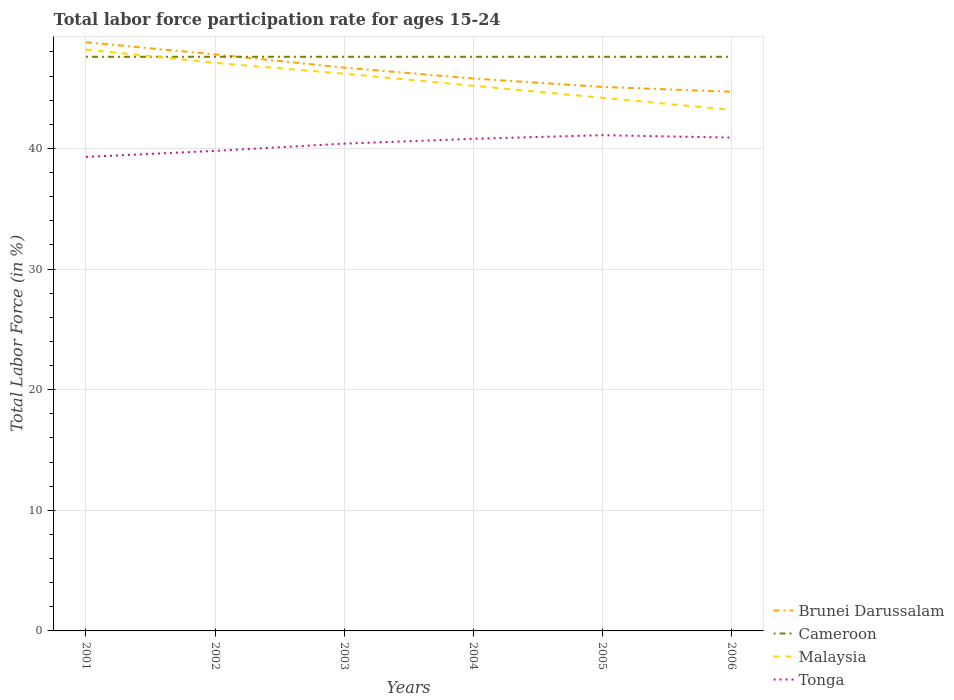How many different coloured lines are there?
Make the answer very short. 4. Does the line corresponding to Malaysia intersect with the line corresponding to Cameroon?
Make the answer very short. Yes. Is the number of lines equal to the number of legend labels?
Ensure brevity in your answer.  Yes. Across all years, what is the maximum labor force participation rate in Malaysia?
Your answer should be very brief. 43.2. What is the total labor force participation rate in Malaysia in the graph?
Ensure brevity in your answer.  2. What is the difference between the highest and the second highest labor force participation rate in Brunei Darussalam?
Offer a terse response. 4.1. Is the labor force participation rate in Brunei Darussalam strictly greater than the labor force participation rate in Malaysia over the years?
Your answer should be very brief. No. How many lines are there?
Your answer should be compact. 4. Are the values on the major ticks of Y-axis written in scientific E-notation?
Your answer should be compact. No. Does the graph contain any zero values?
Ensure brevity in your answer.  No. How are the legend labels stacked?
Offer a very short reply. Vertical. What is the title of the graph?
Keep it short and to the point. Total labor force participation rate for ages 15-24. What is the label or title of the X-axis?
Offer a terse response. Years. What is the label or title of the Y-axis?
Make the answer very short. Total Labor Force (in %). What is the Total Labor Force (in %) in Brunei Darussalam in 2001?
Your answer should be very brief. 48.8. What is the Total Labor Force (in %) of Cameroon in 2001?
Offer a terse response. 47.6. What is the Total Labor Force (in %) in Malaysia in 2001?
Keep it short and to the point. 48.2. What is the Total Labor Force (in %) in Tonga in 2001?
Your answer should be very brief. 39.3. What is the Total Labor Force (in %) in Brunei Darussalam in 2002?
Provide a short and direct response. 47.8. What is the Total Labor Force (in %) of Cameroon in 2002?
Make the answer very short. 47.6. What is the Total Labor Force (in %) of Malaysia in 2002?
Provide a succinct answer. 47.1. What is the Total Labor Force (in %) of Tonga in 2002?
Ensure brevity in your answer.  39.8. What is the Total Labor Force (in %) in Brunei Darussalam in 2003?
Ensure brevity in your answer.  46.7. What is the Total Labor Force (in %) of Cameroon in 2003?
Your answer should be very brief. 47.6. What is the Total Labor Force (in %) in Malaysia in 2003?
Keep it short and to the point. 46.2. What is the Total Labor Force (in %) of Tonga in 2003?
Provide a succinct answer. 40.4. What is the Total Labor Force (in %) of Brunei Darussalam in 2004?
Your answer should be very brief. 45.8. What is the Total Labor Force (in %) in Cameroon in 2004?
Ensure brevity in your answer.  47.6. What is the Total Labor Force (in %) of Malaysia in 2004?
Your response must be concise. 45.2. What is the Total Labor Force (in %) in Tonga in 2004?
Your response must be concise. 40.8. What is the Total Labor Force (in %) of Brunei Darussalam in 2005?
Provide a short and direct response. 45.1. What is the Total Labor Force (in %) in Cameroon in 2005?
Your answer should be very brief. 47.6. What is the Total Labor Force (in %) of Malaysia in 2005?
Your answer should be compact. 44.2. What is the Total Labor Force (in %) in Tonga in 2005?
Provide a succinct answer. 41.1. What is the Total Labor Force (in %) of Brunei Darussalam in 2006?
Keep it short and to the point. 44.7. What is the Total Labor Force (in %) of Cameroon in 2006?
Ensure brevity in your answer.  47.6. What is the Total Labor Force (in %) of Malaysia in 2006?
Offer a terse response. 43.2. What is the Total Labor Force (in %) of Tonga in 2006?
Give a very brief answer. 40.9. Across all years, what is the maximum Total Labor Force (in %) of Brunei Darussalam?
Give a very brief answer. 48.8. Across all years, what is the maximum Total Labor Force (in %) in Cameroon?
Your response must be concise. 47.6. Across all years, what is the maximum Total Labor Force (in %) in Malaysia?
Your response must be concise. 48.2. Across all years, what is the maximum Total Labor Force (in %) in Tonga?
Keep it short and to the point. 41.1. Across all years, what is the minimum Total Labor Force (in %) in Brunei Darussalam?
Offer a terse response. 44.7. Across all years, what is the minimum Total Labor Force (in %) of Cameroon?
Provide a succinct answer. 47.6. Across all years, what is the minimum Total Labor Force (in %) of Malaysia?
Your answer should be very brief. 43.2. Across all years, what is the minimum Total Labor Force (in %) of Tonga?
Keep it short and to the point. 39.3. What is the total Total Labor Force (in %) in Brunei Darussalam in the graph?
Ensure brevity in your answer.  278.9. What is the total Total Labor Force (in %) of Cameroon in the graph?
Keep it short and to the point. 285.6. What is the total Total Labor Force (in %) of Malaysia in the graph?
Provide a succinct answer. 274.1. What is the total Total Labor Force (in %) in Tonga in the graph?
Provide a short and direct response. 242.3. What is the difference between the Total Labor Force (in %) in Brunei Darussalam in 2001 and that in 2002?
Ensure brevity in your answer.  1. What is the difference between the Total Labor Force (in %) in Brunei Darussalam in 2001 and that in 2003?
Your answer should be compact. 2.1. What is the difference between the Total Labor Force (in %) in Tonga in 2001 and that in 2003?
Provide a short and direct response. -1.1. What is the difference between the Total Labor Force (in %) in Tonga in 2001 and that in 2004?
Your answer should be compact. -1.5. What is the difference between the Total Labor Force (in %) of Cameroon in 2001 and that in 2005?
Your response must be concise. 0. What is the difference between the Total Labor Force (in %) in Tonga in 2001 and that in 2005?
Ensure brevity in your answer.  -1.8. What is the difference between the Total Labor Force (in %) of Brunei Darussalam in 2001 and that in 2006?
Make the answer very short. 4.1. What is the difference between the Total Labor Force (in %) of Cameroon in 2001 and that in 2006?
Offer a terse response. 0. What is the difference between the Total Labor Force (in %) in Malaysia in 2001 and that in 2006?
Keep it short and to the point. 5. What is the difference between the Total Labor Force (in %) in Tonga in 2002 and that in 2003?
Provide a succinct answer. -0.6. What is the difference between the Total Labor Force (in %) of Brunei Darussalam in 2002 and that in 2004?
Offer a terse response. 2. What is the difference between the Total Labor Force (in %) in Cameroon in 2002 and that in 2004?
Give a very brief answer. 0. What is the difference between the Total Labor Force (in %) of Malaysia in 2002 and that in 2004?
Provide a succinct answer. 1.9. What is the difference between the Total Labor Force (in %) in Tonga in 2002 and that in 2004?
Provide a short and direct response. -1. What is the difference between the Total Labor Force (in %) in Malaysia in 2002 and that in 2005?
Keep it short and to the point. 2.9. What is the difference between the Total Labor Force (in %) of Brunei Darussalam in 2002 and that in 2006?
Provide a succinct answer. 3.1. What is the difference between the Total Labor Force (in %) of Cameroon in 2002 and that in 2006?
Your answer should be compact. 0. What is the difference between the Total Labor Force (in %) of Tonga in 2002 and that in 2006?
Provide a succinct answer. -1.1. What is the difference between the Total Labor Force (in %) of Brunei Darussalam in 2003 and that in 2004?
Provide a succinct answer. 0.9. What is the difference between the Total Labor Force (in %) in Malaysia in 2003 and that in 2004?
Keep it short and to the point. 1. What is the difference between the Total Labor Force (in %) in Brunei Darussalam in 2003 and that in 2005?
Keep it short and to the point. 1.6. What is the difference between the Total Labor Force (in %) in Tonga in 2003 and that in 2005?
Offer a very short reply. -0.7. What is the difference between the Total Labor Force (in %) of Brunei Darussalam in 2003 and that in 2006?
Provide a short and direct response. 2. What is the difference between the Total Labor Force (in %) in Tonga in 2003 and that in 2006?
Ensure brevity in your answer.  -0.5. What is the difference between the Total Labor Force (in %) in Brunei Darussalam in 2004 and that in 2005?
Your answer should be compact. 0.7. What is the difference between the Total Labor Force (in %) of Cameroon in 2004 and that in 2005?
Provide a succinct answer. 0. What is the difference between the Total Labor Force (in %) of Malaysia in 2004 and that in 2005?
Your answer should be very brief. 1. What is the difference between the Total Labor Force (in %) in Brunei Darussalam in 2004 and that in 2006?
Provide a short and direct response. 1.1. What is the difference between the Total Labor Force (in %) in Tonga in 2004 and that in 2006?
Ensure brevity in your answer.  -0.1. What is the difference between the Total Labor Force (in %) of Brunei Darussalam in 2005 and that in 2006?
Provide a succinct answer. 0.4. What is the difference between the Total Labor Force (in %) of Cameroon in 2005 and that in 2006?
Provide a short and direct response. 0. What is the difference between the Total Labor Force (in %) of Brunei Darussalam in 2001 and the Total Labor Force (in %) of Malaysia in 2002?
Keep it short and to the point. 1.7. What is the difference between the Total Labor Force (in %) of Malaysia in 2001 and the Total Labor Force (in %) of Tonga in 2002?
Make the answer very short. 8.4. What is the difference between the Total Labor Force (in %) in Brunei Darussalam in 2001 and the Total Labor Force (in %) in Cameroon in 2003?
Offer a very short reply. 1.2. What is the difference between the Total Labor Force (in %) in Brunei Darussalam in 2001 and the Total Labor Force (in %) in Malaysia in 2003?
Ensure brevity in your answer.  2.6. What is the difference between the Total Labor Force (in %) of Brunei Darussalam in 2001 and the Total Labor Force (in %) of Tonga in 2003?
Give a very brief answer. 8.4. What is the difference between the Total Labor Force (in %) in Cameroon in 2001 and the Total Labor Force (in %) in Malaysia in 2003?
Your answer should be very brief. 1.4. What is the difference between the Total Labor Force (in %) of Cameroon in 2001 and the Total Labor Force (in %) of Tonga in 2003?
Make the answer very short. 7.2. What is the difference between the Total Labor Force (in %) in Cameroon in 2001 and the Total Labor Force (in %) in Malaysia in 2004?
Provide a succinct answer. 2.4. What is the difference between the Total Labor Force (in %) in Brunei Darussalam in 2001 and the Total Labor Force (in %) in Cameroon in 2005?
Give a very brief answer. 1.2. What is the difference between the Total Labor Force (in %) of Cameroon in 2001 and the Total Labor Force (in %) of Malaysia in 2005?
Ensure brevity in your answer.  3.4. What is the difference between the Total Labor Force (in %) of Malaysia in 2001 and the Total Labor Force (in %) of Tonga in 2005?
Keep it short and to the point. 7.1. What is the difference between the Total Labor Force (in %) of Brunei Darussalam in 2001 and the Total Labor Force (in %) of Cameroon in 2006?
Offer a very short reply. 1.2. What is the difference between the Total Labor Force (in %) of Cameroon in 2001 and the Total Labor Force (in %) of Malaysia in 2006?
Offer a very short reply. 4.4. What is the difference between the Total Labor Force (in %) of Cameroon in 2001 and the Total Labor Force (in %) of Tonga in 2006?
Give a very brief answer. 6.7. What is the difference between the Total Labor Force (in %) in Malaysia in 2001 and the Total Labor Force (in %) in Tonga in 2006?
Keep it short and to the point. 7.3. What is the difference between the Total Labor Force (in %) of Brunei Darussalam in 2002 and the Total Labor Force (in %) of Cameroon in 2003?
Ensure brevity in your answer.  0.2. What is the difference between the Total Labor Force (in %) in Brunei Darussalam in 2002 and the Total Labor Force (in %) in Cameroon in 2004?
Give a very brief answer. 0.2. What is the difference between the Total Labor Force (in %) of Brunei Darussalam in 2002 and the Total Labor Force (in %) of Tonga in 2004?
Ensure brevity in your answer.  7. What is the difference between the Total Labor Force (in %) in Brunei Darussalam in 2002 and the Total Labor Force (in %) in Cameroon in 2005?
Your answer should be compact. 0.2. What is the difference between the Total Labor Force (in %) of Brunei Darussalam in 2002 and the Total Labor Force (in %) of Malaysia in 2005?
Provide a succinct answer. 3.6. What is the difference between the Total Labor Force (in %) of Cameroon in 2002 and the Total Labor Force (in %) of Malaysia in 2005?
Provide a succinct answer. 3.4. What is the difference between the Total Labor Force (in %) in Brunei Darussalam in 2002 and the Total Labor Force (in %) in Tonga in 2006?
Give a very brief answer. 6.9. What is the difference between the Total Labor Force (in %) of Cameroon in 2002 and the Total Labor Force (in %) of Malaysia in 2006?
Your answer should be very brief. 4.4. What is the difference between the Total Labor Force (in %) of Cameroon in 2002 and the Total Labor Force (in %) of Tonga in 2006?
Ensure brevity in your answer.  6.7. What is the difference between the Total Labor Force (in %) in Cameroon in 2003 and the Total Labor Force (in %) in Malaysia in 2004?
Ensure brevity in your answer.  2.4. What is the difference between the Total Labor Force (in %) in Cameroon in 2003 and the Total Labor Force (in %) in Tonga in 2004?
Offer a terse response. 6.8. What is the difference between the Total Labor Force (in %) of Malaysia in 2003 and the Total Labor Force (in %) of Tonga in 2004?
Your answer should be compact. 5.4. What is the difference between the Total Labor Force (in %) of Brunei Darussalam in 2003 and the Total Labor Force (in %) of Tonga in 2005?
Your answer should be very brief. 5.6. What is the difference between the Total Labor Force (in %) of Cameroon in 2003 and the Total Labor Force (in %) of Tonga in 2005?
Your answer should be very brief. 6.5. What is the difference between the Total Labor Force (in %) of Malaysia in 2003 and the Total Labor Force (in %) of Tonga in 2005?
Keep it short and to the point. 5.1. What is the difference between the Total Labor Force (in %) of Brunei Darussalam in 2003 and the Total Labor Force (in %) of Malaysia in 2006?
Make the answer very short. 3.5. What is the difference between the Total Labor Force (in %) of Cameroon in 2003 and the Total Labor Force (in %) of Malaysia in 2006?
Give a very brief answer. 4.4. What is the difference between the Total Labor Force (in %) in Malaysia in 2003 and the Total Labor Force (in %) in Tonga in 2006?
Make the answer very short. 5.3. What is the difference between the Total Labor Force (in %) in Cameroon in 2004 and the Total Labor Force (in %) in Malaysia in 2005?
Offer a terse response. 3.4. What is the difference between the Total Labor Force (in %) in Malaysia in 2004 and the Total Labor Force (in %) in Tonga in 2005?
Make the answer very short. 4.1. What is the difference between the Total Labor Force (in %) in Brunei Darussalam in 2004 and the Total Labor Force (in %) in Cameroon in 2006?
Keep it short and to the point. -1.8. What is the difference between the Total Labor Force (in %) of Brunei Darussalam in 2004 and the Total Labor Force (in %) of Tonga in 2006?
Offer a very short reply. 4.9. What is the difference between the Total Labor Force (in %) of Cameroon in 2004 and the Total Labor Force (in %) of Malaysia in 2006?
Keep it short and to the point. 4.4. What is the difference between the Total Labor Force (in %) in Cameroon in 2004 and the Total Labor Force (in %) in Tonga in 2006?
Provide a succinct answer. 6.7. What is the difference between the Total Labor Force (in %) in Malaysia in 2004 and the Total Labor Force (in %) in Tonga in 2006?
Give a very brief answer. 4.3. What is the difference between the Total Labor Force (in %) in Brunei Darussalam in 2005 and the Total Labor Force (in %) in Malaysia in 2006?
Provide a short and direct response. 1.9. What is the average Total Labor Force (in %) of Brunei Darussalam per year?
Your answer should be very brief. 46.48. What is the average Total Labor Force (in %) in Cameroon per year?
Offer a terse response. 47.6. What is the average Total Labor Force (in %) in Malaysia per year?
Offer a very short reply. 45.68. What is the average Total Labor Force (in %) in Tonga per year?
Give a very brief answer. 40.38. In the year 2001, what is the difference between the Total Labor Force (in %) in Brunei Darussalam and Total Labor Force (in %) in Tonga?
Offer a terse response. 9.5. In the year 2001, what is the difference between the Total Labor Force (in %) in Cameroon and Total Labor Force (in %) in Tonga?
Your answer should be very brief. 8.3. In the year 2001, what is the difference between the Total Labor Force (in %) of Malaysia and Total Labor Force (in %) of Tonga?
Your response must be concise. 8.9. In the year 2002, what is the difference between the Total Labor Force (in %) of Brunei Darussalam and Total Labor Force (in %) of Cameroon?
Your answer should be very brief. 0.2. In the year 2002, what is the difference between the Total Labor Force (in %) in Brunei Darussalam and Total Labor Force (in %) in Malaysia?
Your answer should be very brief. 0.7. In the year 2002, what is the difference between the Total Labor Force (in %) of Brunei Darussalam and Total Labor Force (in %) of Tonga?
Provide a short and direct response. 8. In the year 2002, what is the difference between the Total Labor Force (in %) of Malaysia and Total Labor Force (in %) of Tonga?
Keep it short and to the point. 7.3. In the year 2003, what is the difference between the Total Labor Force (in %) in Brunei Darussalam and Total Labor Force (in %) in Malaysia?
Ensure brevity in your answer.  0.5. In the year 2003, what is the difference between the Total Labor Force (in %) of Brunei Darussalam and Total Labor Force (in %) of Tonga?
Ensure brevity in your answer.  6.3. In the year 2003, what is the difference between the Total Labor Force (in %) in Cameroon and Total Labor Force (in %) in Malaysia?
Your response must be concise. 1.4. In the year 2003, what is the difference between the Total Labor Force (in %) of Malaysia and Total Labor Force (in %) of Tonga?
Your response must be concise. 5.8. In the year 2004, what is the difference between the Total Labor Force (in %) in Brunei Darussalam and Total Labor Force (in %) in Cameroon?
Make the answer very short. -1.8. In the year 2004, what is the difference between the Total Labor Force (in %) in Brunei Darussalam and Total Labor Force (in %) in Malaysia?
Your answer should be very brief. 0.6. In the year 2004, what is the difference between the Total Labor Force (in %) of Brunei Darussalam and Total Labor Force (in %) of Tonga?
Make the answer very short. 5. In the year 2004, what is the difference between the Total Labor Force (in %) of Cameroon and Total Labor Force (in %) of Malaysia?
Ensure brevity in your answer.  2.4. In the year 2005, what is the difference between the Total Labor Force (in %) in Brunei Darussalam and Total Labor Force (in %) in Cameroon?
Provide a short and direct response. -2.5. In the year 2005, what is the difference between the Total Labor Force (in %) of Brunei Darussalam and Total Labor Force (in %) of Tonga?
Your answer should be very brief. 4. In the year 2005, what is the difference between the Total Labor Force (in %) in Cameroon and Total Labor Force (in %) in Malaysia?
Your answer should be compact. 3.4. In the year 2005, what is the difference between the Total Labor Force (in %) in Malaysia and Total Labor Force (in %) in Tonga?
Your response must be concise. 3.1. In the year 2006, what is the difference between the Total Labor Force (in %) in Brunei Darussalam and Total Labor Force (in %) in Cameroon?
Give a very brief answer. -2.9. In the year 2006, what is the difference between the Total Labor Force (in %) of Cameroon and Total Labor Force (in %) of Malaysia?
Offer a terse response. 4.4. In the year 2006, what is the difference between the Total Labor Force (in %) of Malaysia and Total Labor Force (in %) of Tonga?
Give a very brief answer. 2.3. What is the ratio of the Total Labor Force (in %) in Brunei Darussalam in 2001 to that in 2002?
Your answer should be compact. 1.02. What is the ratio of the Total Labor Force (in %) of Malaysia in 2001 to that in 2002?
Keep it short and to the point. 1.02. What is the ratio of the Total Labor Force (in %) of Tonga in 2001 to that in 2002?
Make the answer very short. 0.99. What is the ratio of the Total Labor Force (in %) of Brunei Darussalam in 2001 to that in 2003?
Your answer should be compact. 1.04. What is the ratio of the Total Labor Force (in %) of Malaysia in 2001 to that in 2003?
Ensure brevity in your answer.  1.04. What is the ratio of the Total Labor Force (in %) in Tonga in 2001 to that in 2003?
Ensure brevity in your answer.  0.97. What is the ratio of the Total Labor Force (in %) of Brunei Darussalam in 2001 to that in 2004?
Make the answer very short. 1.07. What is the ratio of the Total Labor Force (in %) of Cameroon in 2001 to that in 2004?
Your answer should be very brief. 1. What is the ratio of the Total Labor Force (in %) in Malaysia in 2001 to that in 2004?
Make the answer very short. 1.07. What is the ratio of the Total Labor Force (in %) in Tonga in 2001 to that in 2004?
Offer a very short reply. 0.96. What is the ratio of the Total Labor Force (in %) of Brunei Darussalam in 2001 to that in 2005?
Provide a short and direct response. 1.08. What is the ratio of the Total Labor Force (in %) in Cameroon in 2001 to that in 2005?
Provide a short and direct response. 1. What is the ratio of the Total Labor Force (in %) in Malaysia in 2001 to that in 2005?
Make the answer very short. 1.09. What is the ratio of the Total Labor Force (in %) of Tonga in 2001 to that in 2005?
Your answer should be very brief. 0.96. What is the ratio of the Total Labor Force (in %) in Brunei Darussalam in 2001 to that in 2006?
Offer a very short reply. 1.09. What is the ratio of the Total Labor Force (in %) of Malaysia in 2001 to that in 2006?
Offer a terse response. 1.12. What is the ratio of the Total Labor Force (in %) in Tonga in 2001 to that in 2006?
Give a very brief answer. 0.96. What is the ratio of the Total Labor Force (in %) in Brunei Darussalam in 2002 to that in 2003?
Provide a short and direct response. 1.02. What is the ratio of the Total Labor Force (in %) in Malaysia in 2002 to that in 2003?
Provide a short and direct response. 1.02. What is the ratio of the Total Labor Force (in %) in Tonga in 2002 to that in 2003?
Keep it short and to the point. 0.99. What is the ratio of the Total Labor Force (in %) in Brunei Darussalam in 2002 to that in 2004?
Ensure brevity in your answer.  1.04. What is the ratio of the Total Labor Force (in %) of Malaysia in 2002 to that in 2004?
Your response must be concise. 1.04. What is the ratio of the Total Labor Force (in %) of Tonga in 2002 to that in 2004?
Your response must be concise. 0.98. What is the ratio of the Total Labor Force (in %) in Brunei Darussalam in 2002 to that in 2005?
Your response must be concise. 1.06. What is the ratio of the Total Labor Force (in %) in Cameroon in 2002 to that in 2005?
Keep it short and to the point. 1. What is the ratio of the Total Labor Force (in %) of Malaysia in 2002 to that in 2005?
Keep it short and to the point. 1.07. What is the ratio of the Total Labor Force (in %) in Tonga in 2002 to that in 2005?
Provide a short and direct response. 0.97. What is the ratio of the Total Labor Force (in %) of Brunei Darussalam in 2002 to that in 2006?
Provide a succinct answer. 1.07. What is the ratio of the Total Labor Force (in %) in Malaysia in 2002 to that in 2006?
Give a very brief answer. 1.09. What is the ratio of the Total Labor Force (in %) in Tonga in 2002 to that in 2006?
Offer a terse response. 0.97. What is the ratio of the Total Labor Force (in %) of Brunei Darussalam in 2003 to that in 2004?
Provide a short and direct response. 1.02. What is the ratio of the Total Labor Force (in %) of Malaysia in 2003 to that in 2004?
Make the answer very short. 1.02. What is the ratio of the Total Labor Force (in %) in Tonga in 2003 to that in 2004?
Keep it short and to the point. 0.99. What is the ratio of the Total Labor Force (in %) of Brunei Darussalam in 2003 to that in 2005?
Offer a terse response. 1.04. What is the ratio of the Total Labor Force (in %) in Malaysia in 2003 to that in 2005?
Ensure brevity in your answer.  1.05. What is the ratio of the Total Labor Force (in %) of Tonga in 2003 to that in 2005?
Make the answer very short. 0.98. What is the ratio of the Total Labor Force (in %) of Brunei Darussalam in 2003 to that in 2006?
Keep it short and to the point. 1.04. What is the ratio of the Total Labor Force (in %) in Cameroon in 2003 to that in 2006?
Provide a succinct answer. 1. What is the ratio of the Total Labor Force (in %) of Malaysia in 2003 to that in 2006?
Make the answer very short. 1.07. What is the ratio of the Total Labor Force (in %) of Brunei Darussalam in 2004 to that in 2005?
Keep it short and to the point. 1.02. What is the ratio of the Total Labor Force (in %) of Malaysia in 2004 to that in 2005?
Provide a short and direct response. 1.02. What is the ratio of the Total Labor Force (in %) of Brunei Darussalam in 2004 to that in 2006?
Give a very brief answer. 1.02. What is the ratio of the Total Labor Force (in %) of Cameroon in 2004 to that in 2006?
Provide a succinct answer. 1. What is the ratio of the Total Labor Force (in %) in Malaysia in 2004 to that in 2006?
Offer a very short reply. 1.05. What is the ratio of the Total Labor Force (in %) of Brunei Darussalam in 2005 to that in 2006?
Your answer should be compact. 1.01. What is the ratio of the Total Labor Force (in %) in Cameroon in 2005 to that in 2006?
Ensure brevity in your answer.  1. What is the ratio of the Total Labor Force (in %) in Malaysia in 2005 to that in 2006?
Provide a short and direct response. 1.02. What is the difference between the highest and the second highest Total Labor Force (in %) in Brunei Darussalam?
Ensure brevity in your answer.  1. What is the difference between the highest and the lowest Total Labor Force (in %) in Cameroon?
Provide a short and direct response. 0. 